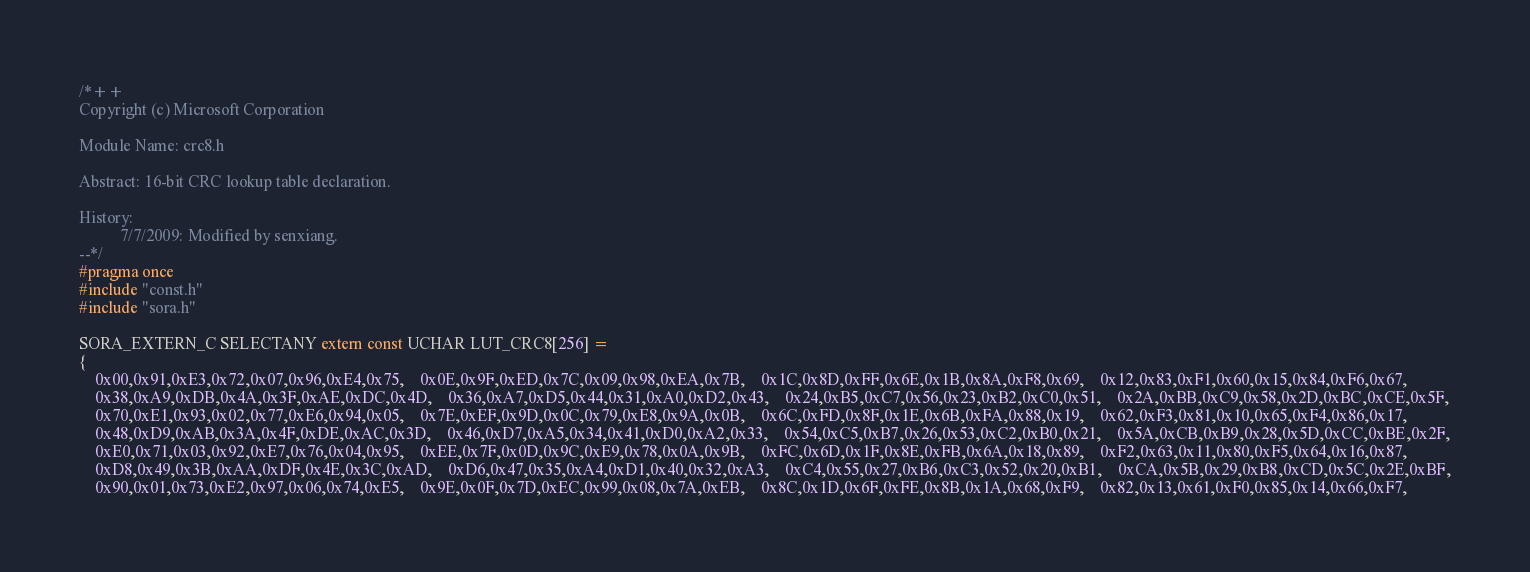<code> <loc_0><loc_0><loc_500><loc_500><_C_>/*++
Copyright (c) Microsoft Corporation

Module Name: crc8.h

Abstract: 16-bit CRC lookup table declaration.

History: 
          7/7/2009: Modified by senxiang.
--*/
#pragma once
#include "const.h"
#include "sora.h"

SORA_EXTERN_C SELECTANY extern const UCHAR LUT_CRC8[256] =
{
    0x00,0x91,0xE3,0x72,0x07,0x96,0xE4,0x75,    0x0E,0x9F,0xED,0x7C,0x09,0x98,0xEA,0x7B,    0x1C,0x8D,0xFF,0x6E,0x1B,0x8A,0xF8,0x69,    0x12,0x83,0xF1,0x60,0x15,0x84,0xF6,0x67,
    0x38,0xA9,0xDB,0x4A,0x3F,0xAE,0xDC,0x4D,    0x36,0xA7,0xD5,0x44,0x31,0xA0,0xD2,0x43,    0x24,0xB5,0xC7,0x56,0x23,0xB2,0xC0,0x51,    0x2A,0xBB,0xC9,0x58,0x2D,0xBC,0xCE,0x5F,
    0x70,0xE1,0x93,0x02,0x77,0xE6,0x94,0x05,    0x7E,0xEF,0x9D,0x0C,0x79,0xE8,0x9A,0x0B,    0x6C,0xFD,0x8F,0x1E,0x6B,0xFA,0x88,0x19,    0x62,0xF3,0x81,0x10,0x65,0xF4,0x86,0x17,
    0x48,0xD9,0xAB,0x3A,0x4F,0xDE,0xAC,0x3D,    0x46,0xD7,0xA5,0x34,0x41,0xD0,0xA2,0x33,    0x54,0xC5,0xB7,0x26,0x53,0xC2,0xB0,0x21,    0x5A,0xCB,0xB9,0x28,0x5D,0xCC,0xBE,0x2F,
    0xE0,0x71,0x03,0x92,0xE7,0x76,0x04,0x95,    0xEE,0x7F,0x0D,0x9C,0xE9,0x78,0x0A,0x9B,    0xFC,0x6D,0x1F,0x8E,0xFB,0x6A,0x18,0x89,    0xF2,0x63,0x11,0x80,0xF5,0x64,0x16,0x87,
    0xD8,0x49,0x3B,0xAA,0xDF,0x4E,0x3C,0xAD,    0xD6,0x47,0x35,0xA4,0xD1,0x40,0x32,0xA3,    0xC4,0x55,0x27,0xB6,0xC3,0x52,0x20,0xB1,    0xCA,0x5B,0x29,0xB8,0xCD,0x5C,0x2E,0xBF,
    0x90,0x01,0x73,0xE2,0x97,0x06,0x74,0xE5,    0x9E,0x0F,0x7D,0xEC,0x99,0x08,0x7A,0xEB,    0x8C,0x1D,0x6F,0xFE,0x8B,0x1A,0x68,0xF9,    0x82,0x13,0x61,0xF0,0x85,0x14,0x66,0xF7,</code> 